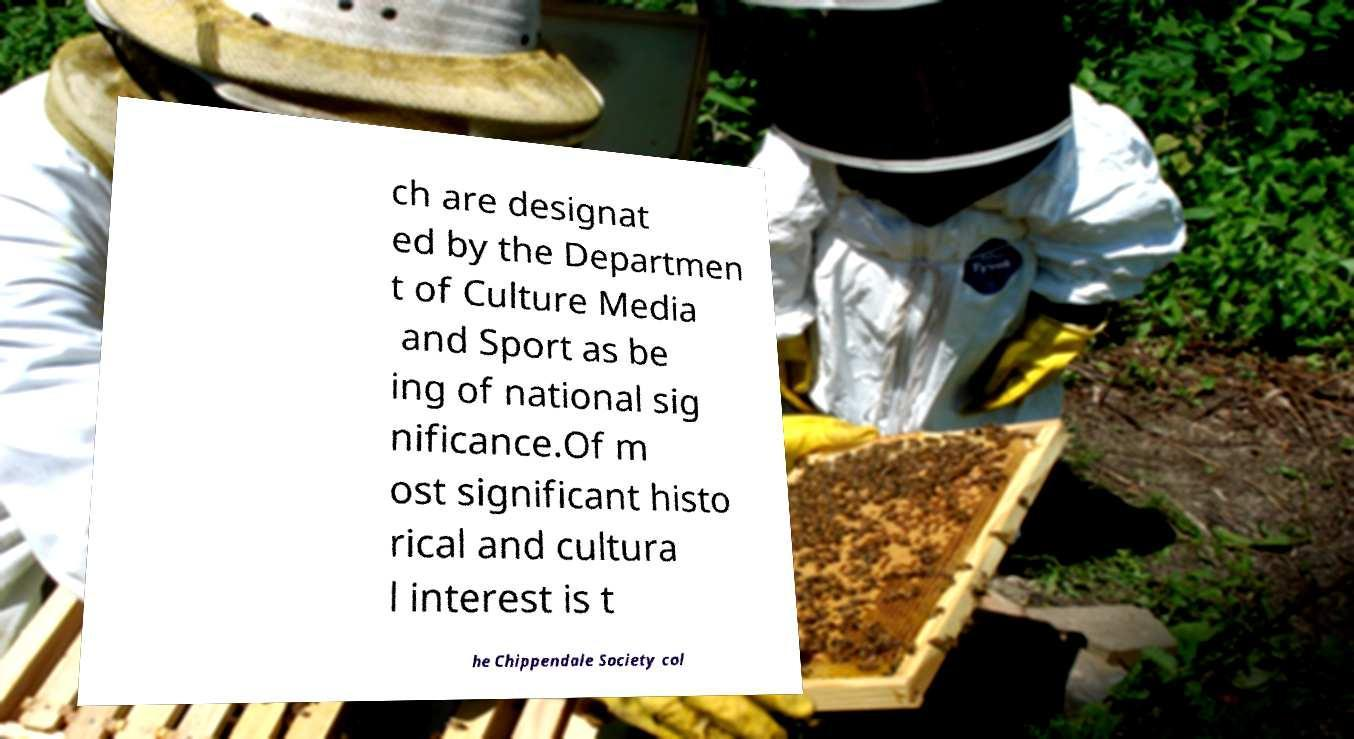Can you accurately transcribe the text from the provided image for me? ch are designat ed by the Departmen t of Culture Media and Sport as be ing of national sig nificance.Of m ost significant histo rical and cultura l interest is t he Chippendale Society col 